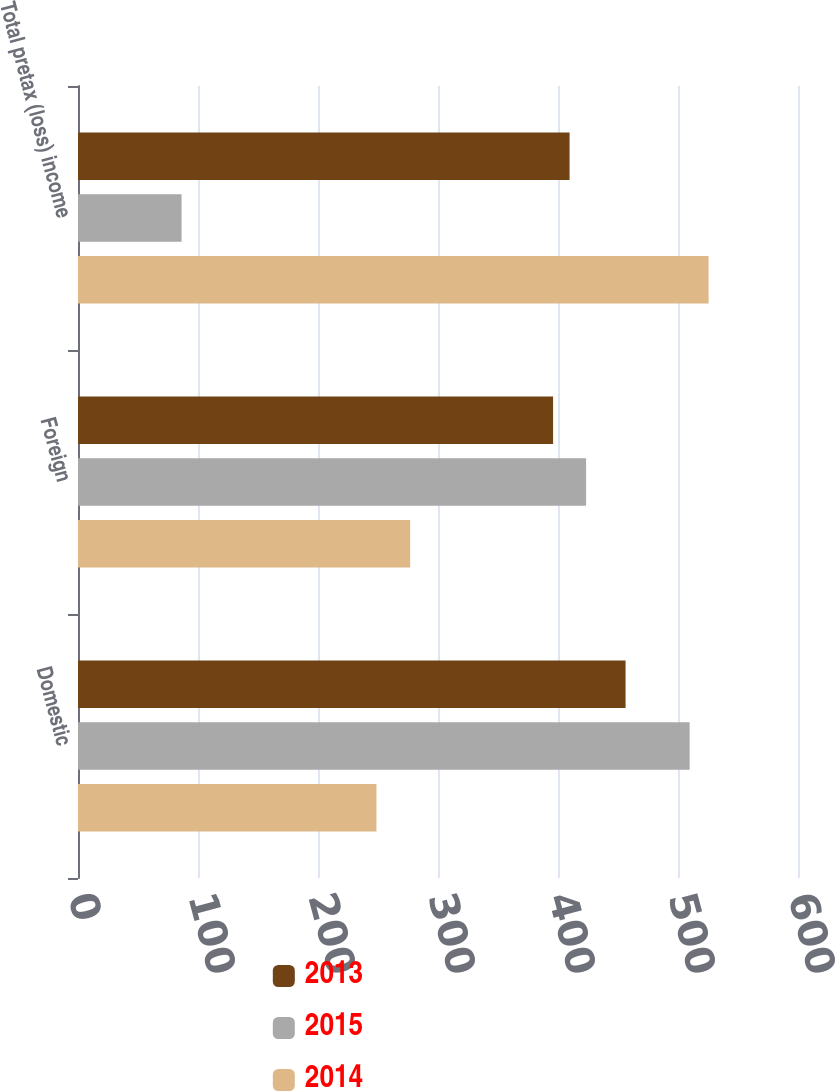Convert chart. <chart><loc_0><loc_0><loc_500><loc_500><stacked_bar_chart><ecel><fcel>Domestic<fcel>Foreign<fcel>Total pretax (loss) income<nl><fcel>2013<fcel>456.3<fcel>395.9<fcel>409.65<nl><fcel>2015<fcel>509.7<fcel>423.4<fcel>86.3<nl><fcel>2014<fcel>248.7<fcel>276.8<fcel>525.5<nl></chart> 